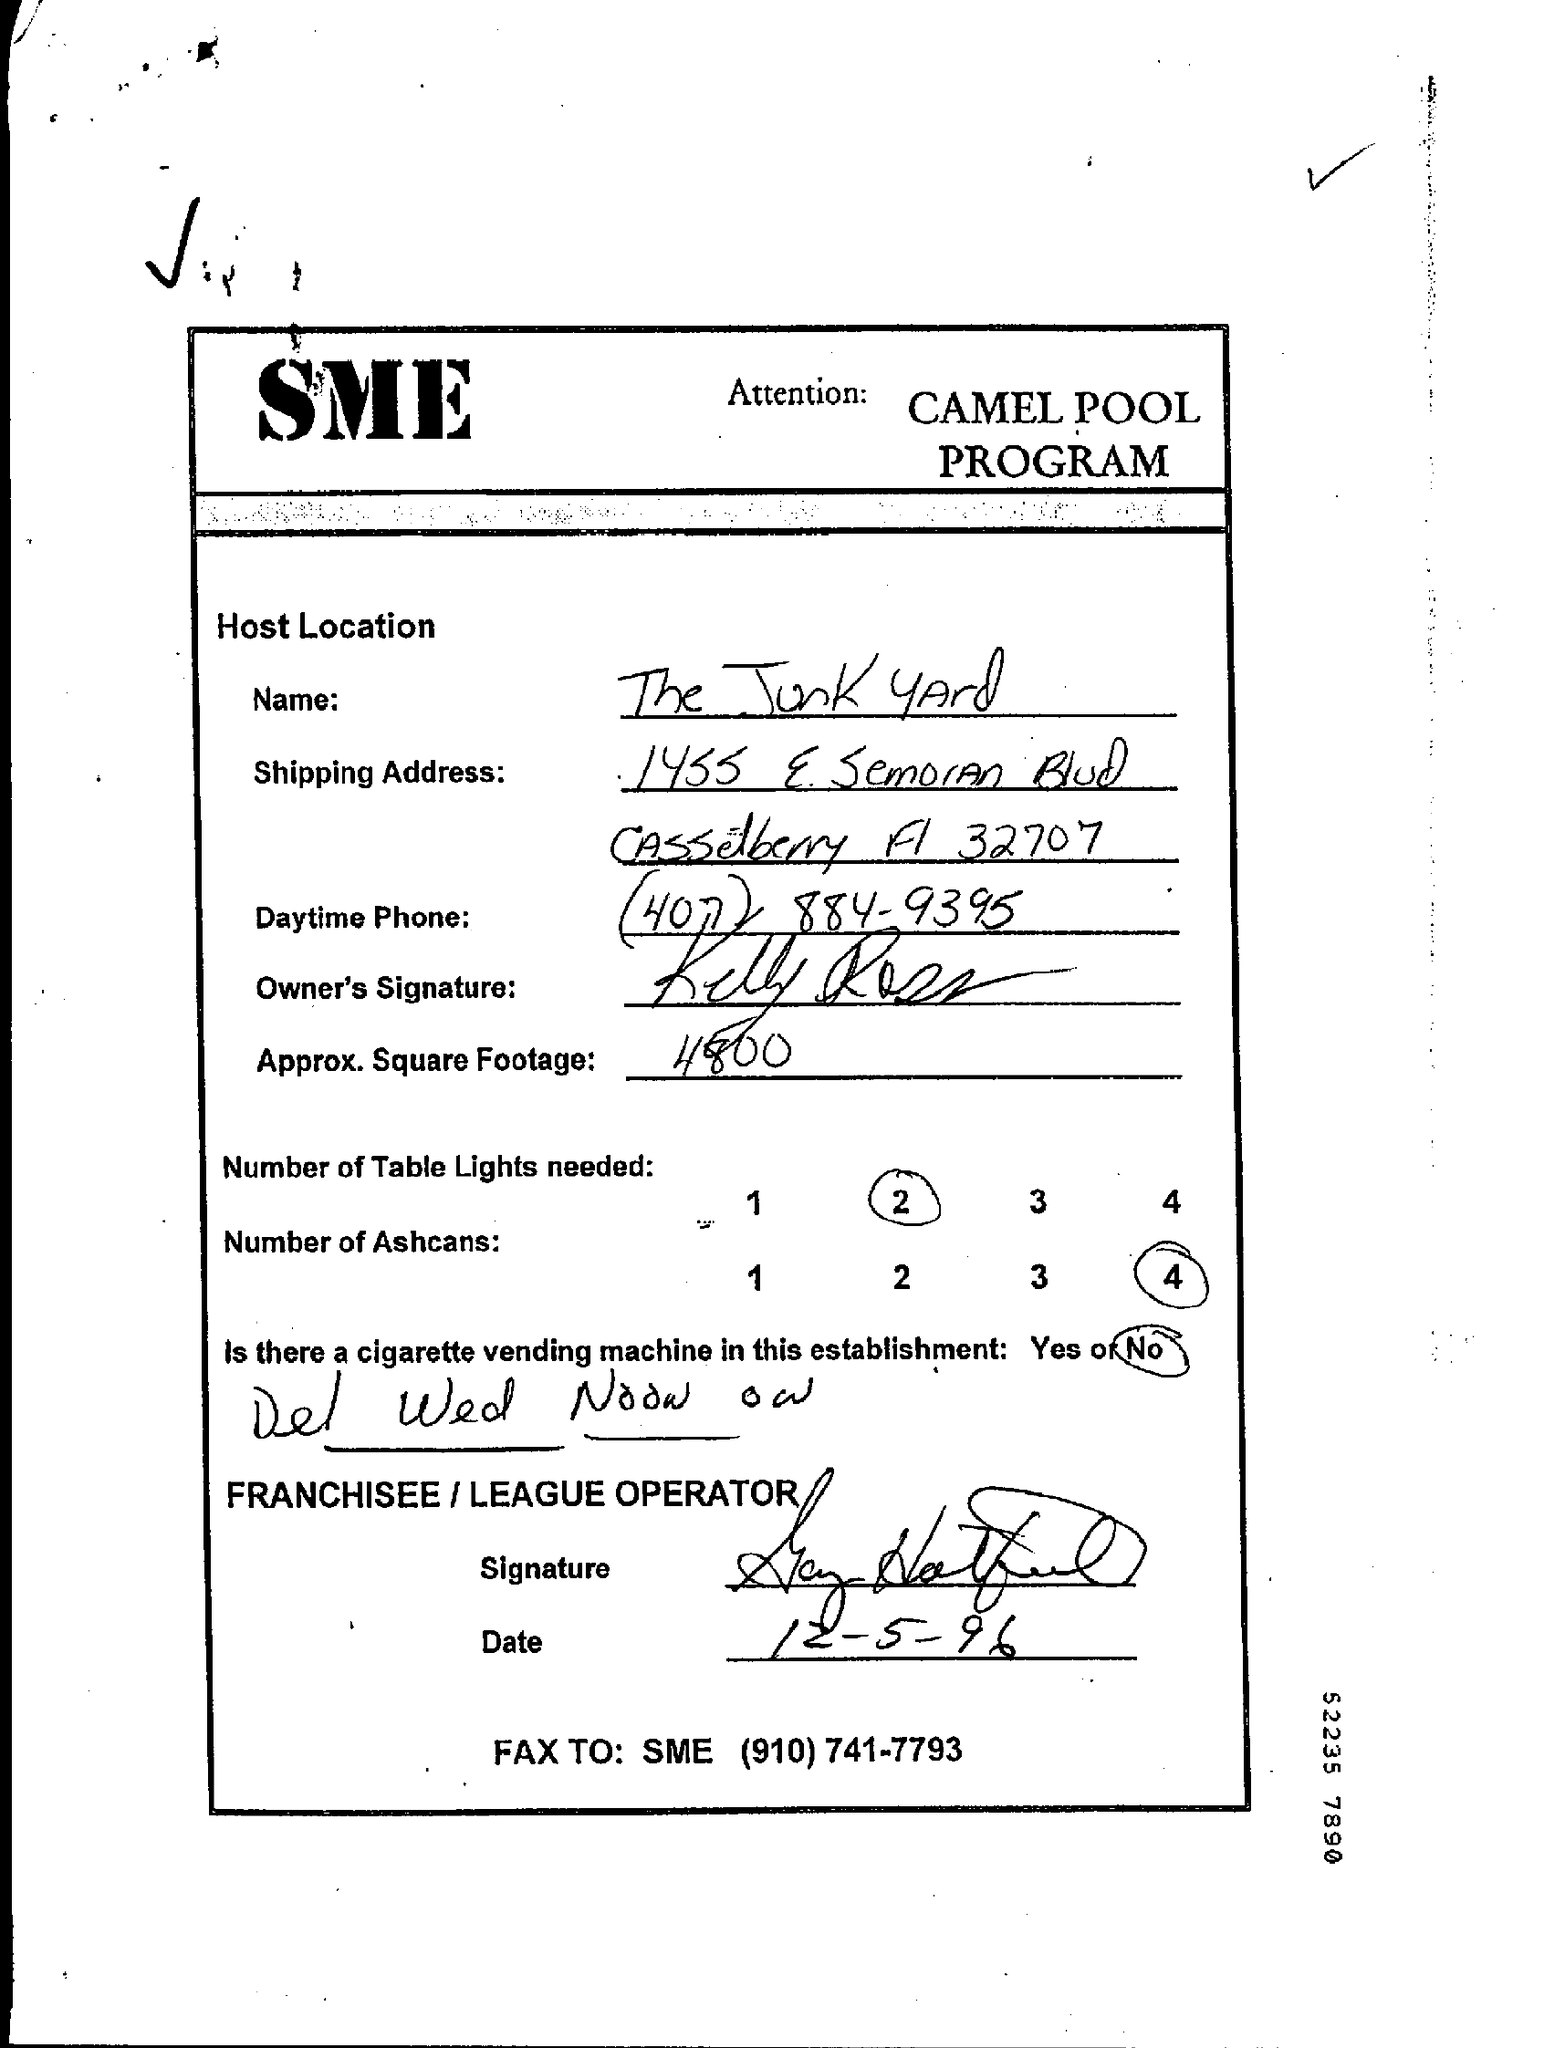What is the Host Location Name?
Offer a terse response. The Junk Yard. What is the Approx. Square Footage?
Ensure brevity in your answer.  4800. What is the Number of Table Lights needed?
Your answer should be compact. 2. What is the Number of Ashcans?
Provide a succinct answer. 4. What is the Date?
Your response must be concise. 12-5-96. 